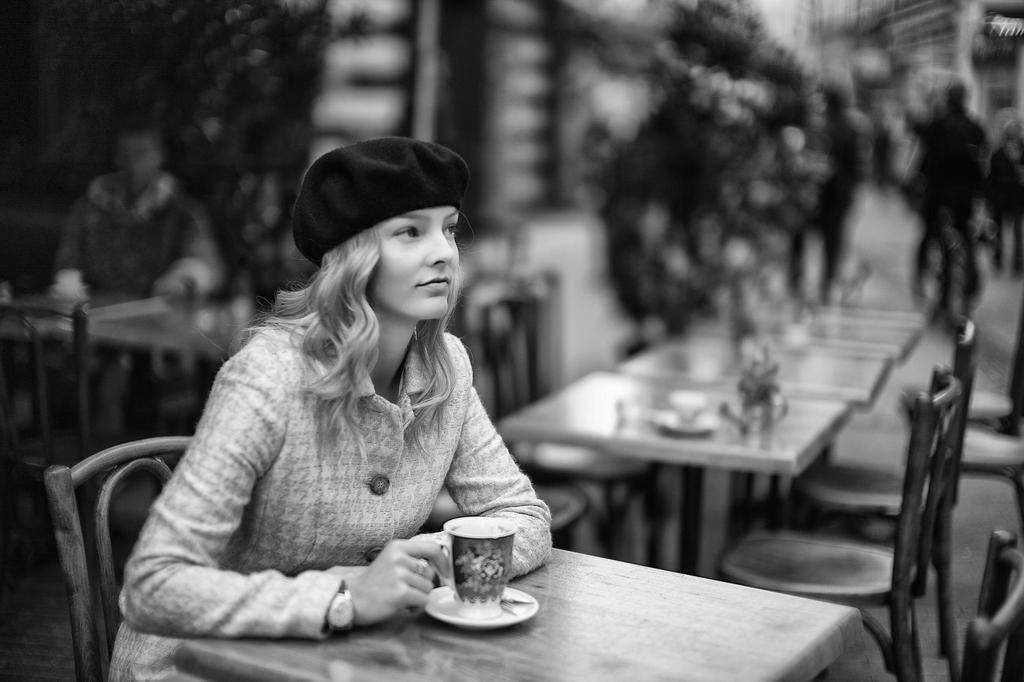Could you give a brief overview of what you see in this image? This is a black and white image. Here is a woman sitting on the chair. This is the table with cup and saucer. At background I can see some tables with chairs and a person sitting here. I think this is a tree and few people walking. 